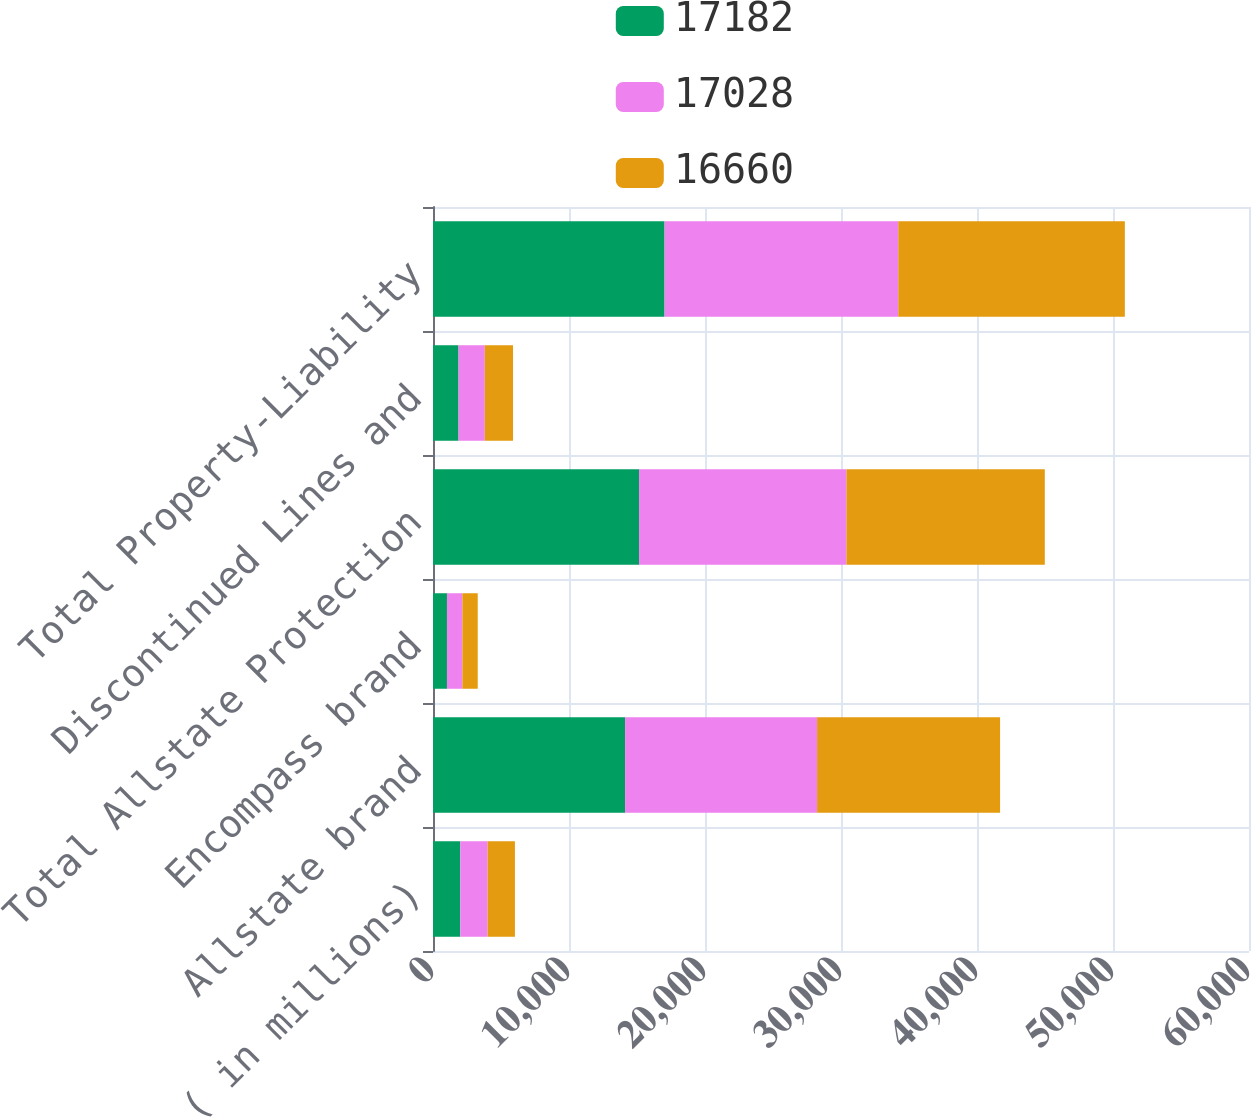Convert chart. <chart><loc_0><loc_0><loc_500><loc_500><stacked_bar_chart><ecel><fcel>( in millions)<fcel>Allstate brand<fcel>Encompass brand<fcel>Total Allstate Protection<fcel>Discontinued Lines and<fcel>Total Property-Liability<nl><fcel>17182<fcel>2009<fcel>14123<fcel>1027<fcel>15150<fcel>1878<fcel>17028<nl><fcel>17028<fcel>2008<fcel>14118<fcel>1133<fcel>15251<fcel>1931<fcel>17182<nl><fcel>16660<fcel>2007<fcel>13456<fcel>1129<fcel>14585<fcel>2075<fcel>16660<nl></chart> 